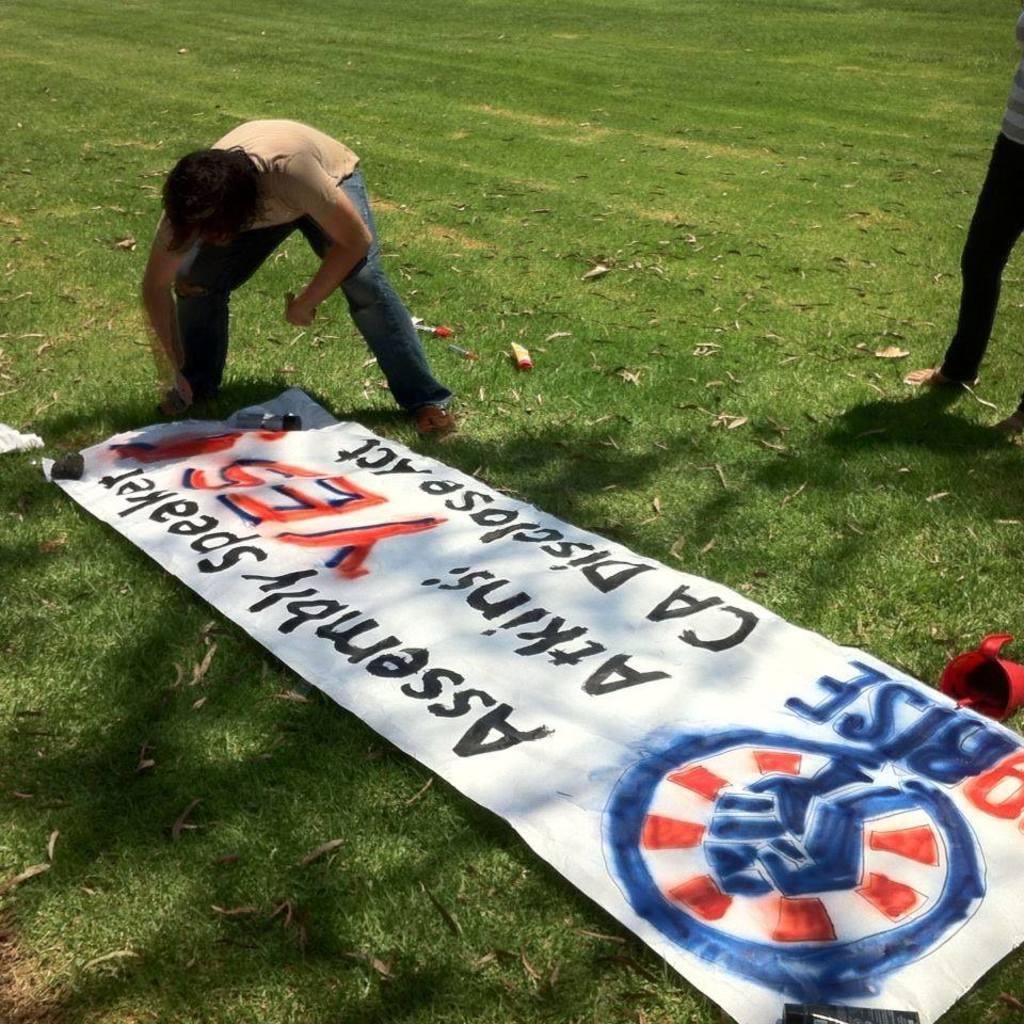How would you summarize this image in a sentence or two? In this image, we can see a banner and some other objects on the ground and there are some other people. 